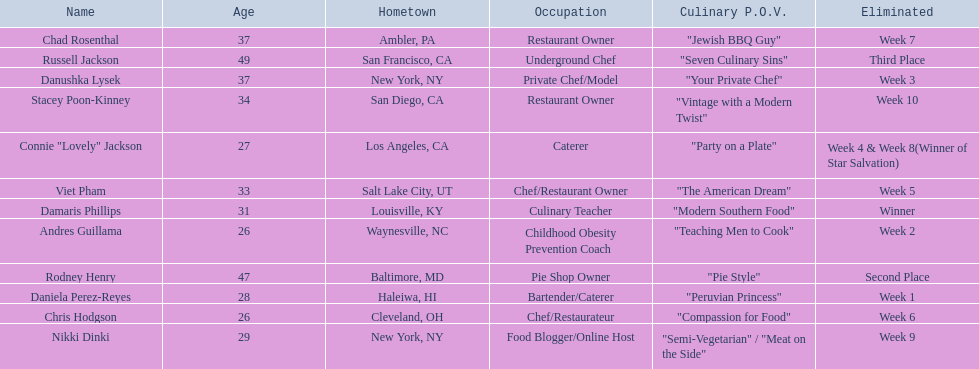Parse the full table. {'header': ['Name', 'Age', 'Hometown', 'Occupation', 'Culinary P.O.V.', 'Eliminated'], 'rows': [['Chad Rosenthal', '37', 'Ambler, PA', 'Restaurant Owner', '"Jewish BBQ Guy"', 'Week 7'], ['Russell Jackson', '49', 'San Francisco, CA', 'Underground Chef', '"Seven Culinary Sins"', 'Third Place'], ['Danushka Lysek', '37', 'New York, NY', 'Private Chef/Model', '"Your Private Chef"', 'Week 3'], ['Stacey Poon-Kinney', '34', 'San Diego, CA', 'Restaurant Owner', '"Vintage with a Modern Twist"', 'Week 10'], ['Connie "Lovely" Jackson', '27', 'Los Angeles, CA', 'Caterer', '"Party on a Plate"', 'Week 4 & Week 8(Winner of Star Salvation)'], ['Viet Pham', '33', 'Salt Lake City, UT', 'Chef/Restaurant Owner', '"The American Dream"', 'Week 5'], ['Damaris Phillips', '31', 'Louisville, KY', 'Culinary Teacher', '"Modern Southern Food"', 'Winner'], ['Andres Guillama', '26', 'Waynesville, NC', 'Childhood Obesity Prevention Coach', '"Teaching Men to Cook"', 'Week 2'], ['Rodney Henry', '47', 'Baltimore, MD', 'Pie Shop Owner', '"Pie Style"', 'Second Place'], ['Daniela Perez-Reyes', '28', 'Haleiwa, HI', 'Bartender/Caterer', '"Peruvian Princess"', 'Week 1'], ['Chris Hodgson', '26', 'Cleveland, OH', 'Chef/Restaurateur', '"Compassion for Food"', 'Week 6'], ['Nikki Dinki', '29', 'New York, NY', 'Food Blogger/Online Host', '"Semi-Vegetarian" / "Meat on the Side"', 'Week 9']]} Who where the people in the food network? Damaris Phillips, Rodney Henry, Russell Jackson, Stacey Poon-Kinney, Nikki Dinki, Chad Rosenthal, Chris Hodgson, Viet Pham, Connie "Lovely" Jackson, Danushka Lysek, Andres Guillama, Daniela Perez-Reyes. When was nikki dinki eliminated? Week 9. When was viet pham eliminated? Week 5. Which of these two is earlier? Week 5. Who was eliminated in this week? Viet Pham. 